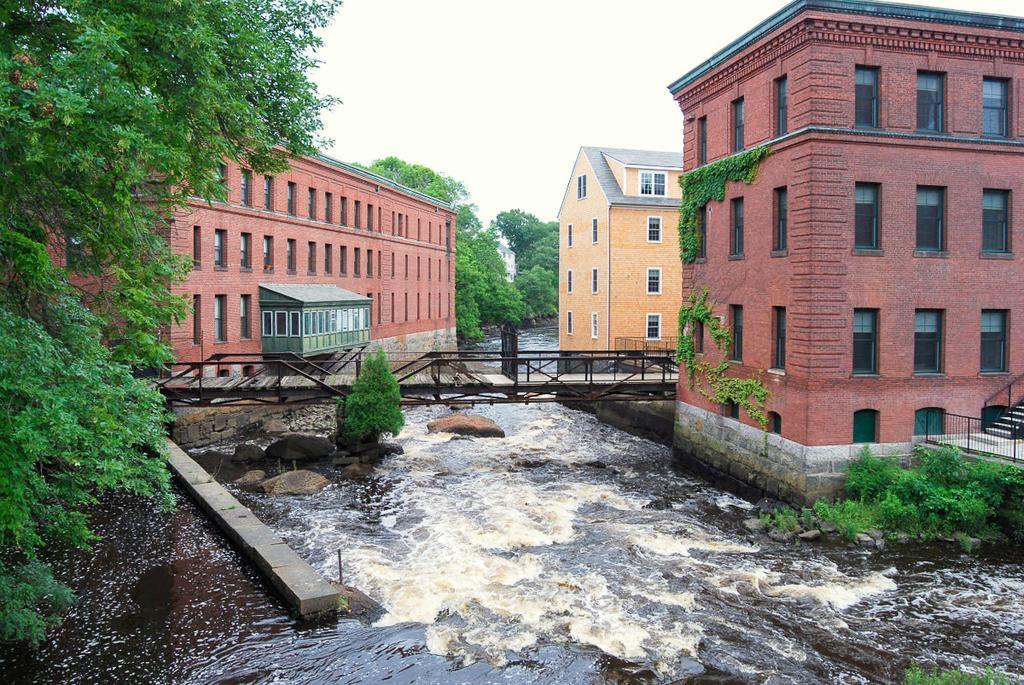In one or two sentences, can you explain what this image depicts? In this image I can see river is flowing in the middle. It is the bridge, there are houses on either side of this image. On the left side there are trees, at the top it is the sky. 